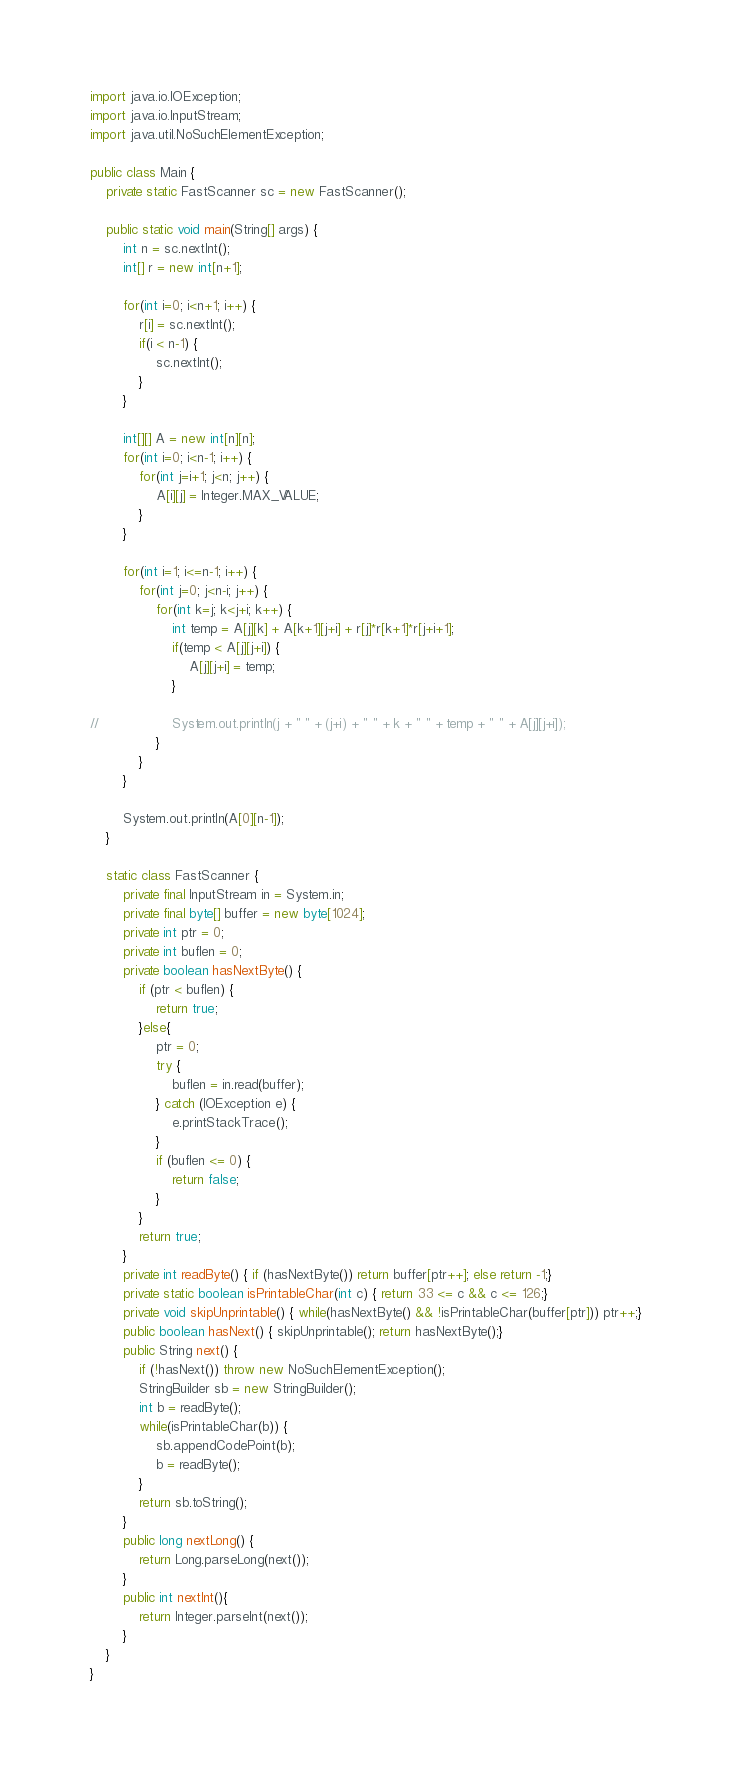<code> <loc_0><loc_0><loc_500><loc_500><_Java_>import java.io.IOException;
import java.io.InputStream;
import java.util.NoSuchElementException;

public class Main {
	private static FastScanner sc = new FastScanner();

	public static void main(String[] args) {
		int n = sc.nextInt();
		int[] r = new int[n+1];
		
		for(int i=0; i<n+1; i++) {
			r[i] = sc.nextInt();
			if(i < n-1) {
				sc.nextInt();
			}
		}
		
		int[][] A = new int[n][n];
		for(int i=0; i<n-1; i++) {
			for(int j=i+1; j<n; j++) {	
				A[i][j] = Integer.MAX_VALUE;
			}
		}
		
		for(int i=1; i<=n-1; i++) {
			for(int j=0; j<n-i; j++) {
				for(int k=j; k<j+i; k++) {
					int temp = A[j][k] + A[k+1][j+i] + r[j]*r[k+1]*r[j+i+1];
					if(temp < A[j][j+i]) {
						A[j][j+i] = temp;
					}
					
//					System.out.println(j + " " + (j+i) + " " + k + " " + temp + " " + A[j][j+i]);
				}
			}
		}
		
		System.out.println(A[0][n-1]);
	}

	static class FastScanner {
	    private final InputStream in = System.in;
	    private final byte[] buffer = new byte[1024];
	    private int ptr = 0;
	    private int buflen = 0;
	    private boolean hasNextByte() {
	        if (ptr < buflen) {
	            return true;
	        }else{
	            ptr = 0;
	            try {
	                buflen = in.read(buffer);
	            } catch (IOException e) {
	                e.printStackTrace();
	            }
	            if (buflen <= 0) {
	                return false;
	            }
	        }
	        return true;
	    }
	    private int readByte() { if (hasNextByte()) return buffer[ptr++]; else return -1;}
	    private static boolean isPrintableChar(int c) { return 33 <= c && c <= 126;}
	    private void skipUnprintable() { while(hasNextByte() && !isPrintableChar(buffer[ptr])) ptr++;}
	    public boolean hasNext() { skipUnprintable(); return hasNextByte();}
	    public String next() {
	        if (!hasNext()) throw new NoSuchElementException();
	        StringBuilder sb = new StringBuilder();
	        int b = readByte();
	        while(isPrintableChar(b)) {
	            sb.appendCodePoint(b);
	            b = readByte();
	        }
	        return sb.toString();
	    }
	    public long nextLong() {
	        return Long.parseLong(next());
	    }
	    public int nextInt(){
	    	return Integer.parseInt(next());
	    }
	}
}</code> 